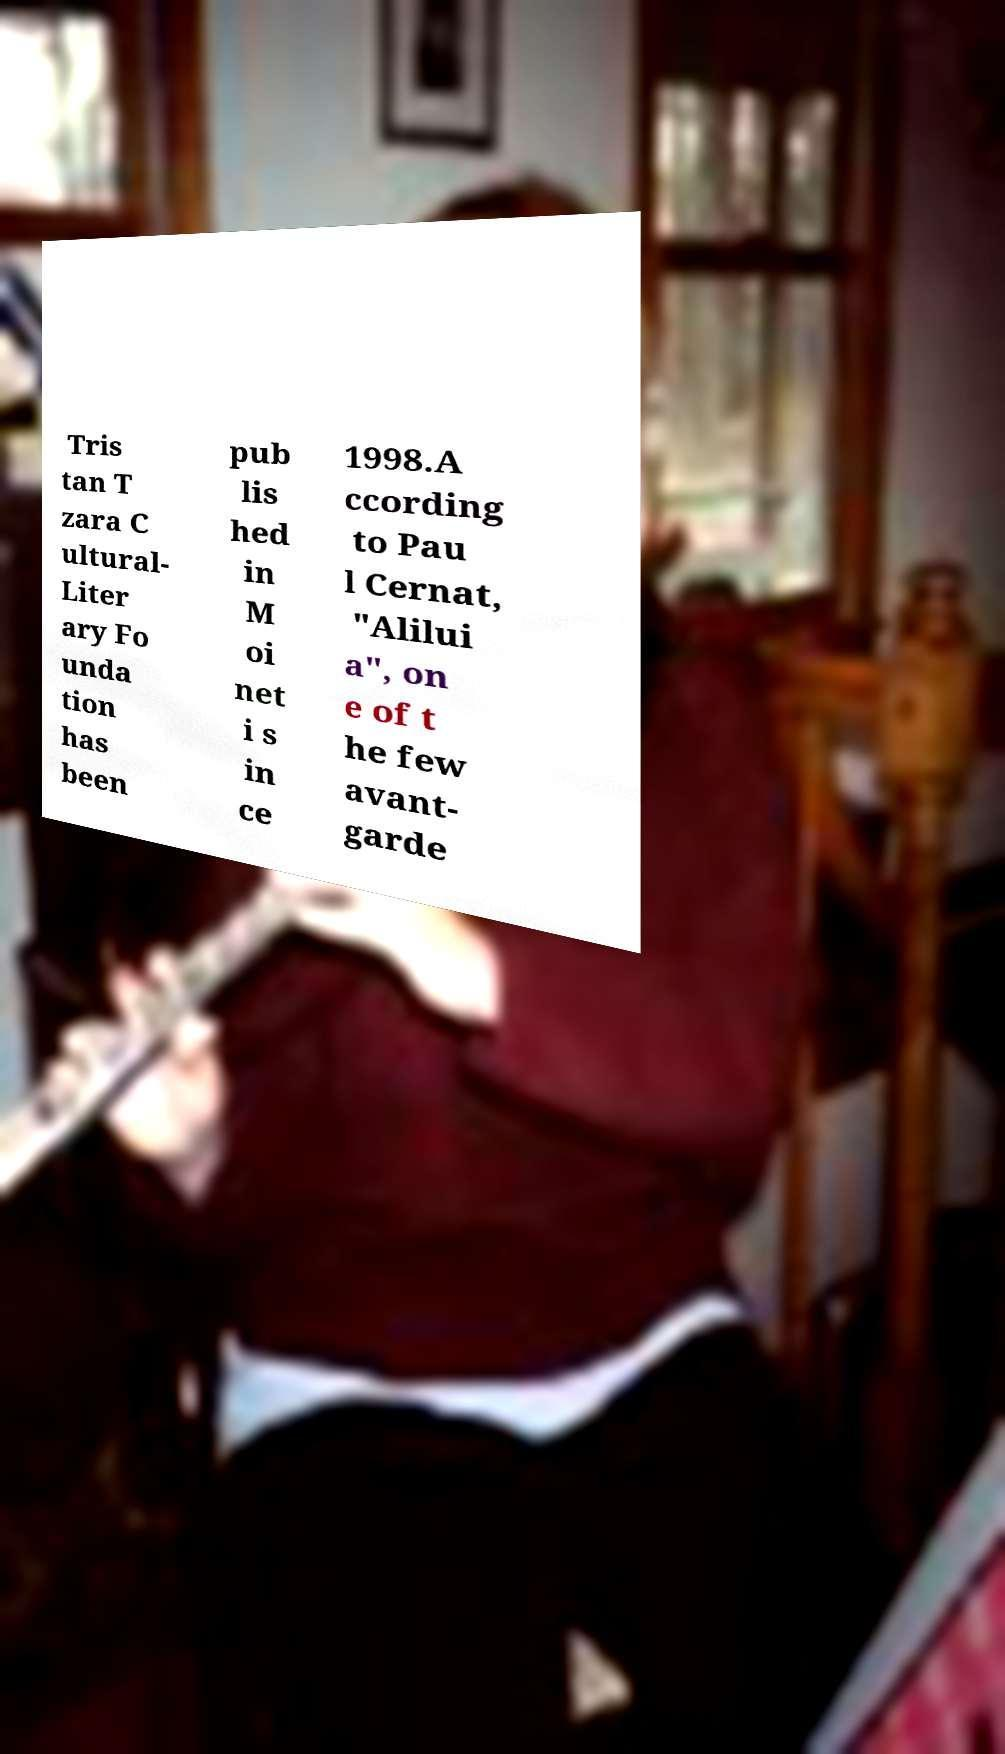Can you read and provide the text displayed in the image?This photo seems to have some interesting text. Can you extract and type it out for me? Tris tan T zara C ultural- Liter ary Fo unda tion has been pub lis hed in M oi net i s in ce 1998.A ccording to Pau l Cernat, "Alilui a", on e of t he few avant- garde 